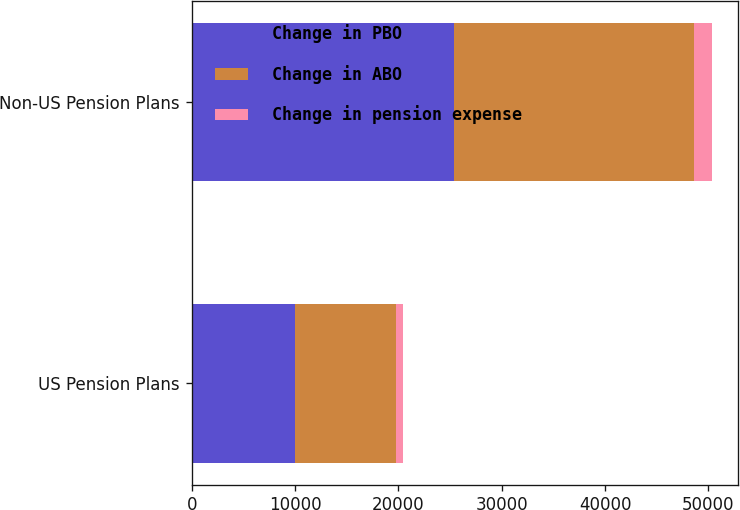Convert chart to OTSL. <chart><loc_0><loc_0><loc_500><loc_500><stacked_bar_chart><ecel><fcel>US Pension Plans<fcel>Non-US Pension Plans<nl><fcel>Change in PBO<fcel>9975<fcel>25406<nl><fcel>Change in ABO<fcel>9784<fcel>23215<nl><fcel>Change in pension expense<fcel>678<fcel>1693<nl></chart> 